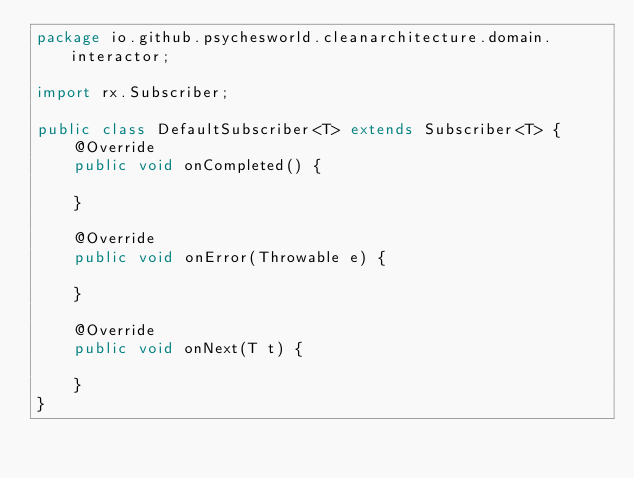<code> <loc_0><loc_0><loc_500><loc_500><_Java_>package io.github.psychesworld.cleanarchitecture.domain.interactor;

import rx.Subscriber;

public class DefaultSubscriber<T> extends Subscriber<T> {
    @Override
    public void onCompleted() {

    }

    @Override
    public void onError(Throwable e) {

    }

    @Override
    public void onNext(T t) {

    }
}
</code> 